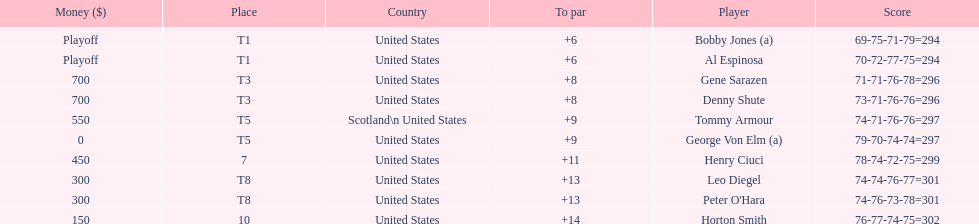Who was the last player in the top 10? Horton Smith. 